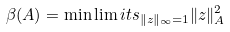<formula> <loc_0><loc_0><loc_500><loc_500>\beta ( A ) = \min \lim i t s _ { \| z \| _ { \infty } = 1 } \| z \| ^ { 2 } _ { A }</formula> 